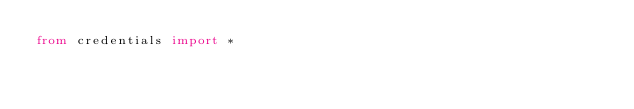Convert code to text. <code><loc_0><loc_0><loc_500><loc_500><_Python_>from credentials import *
</code> 